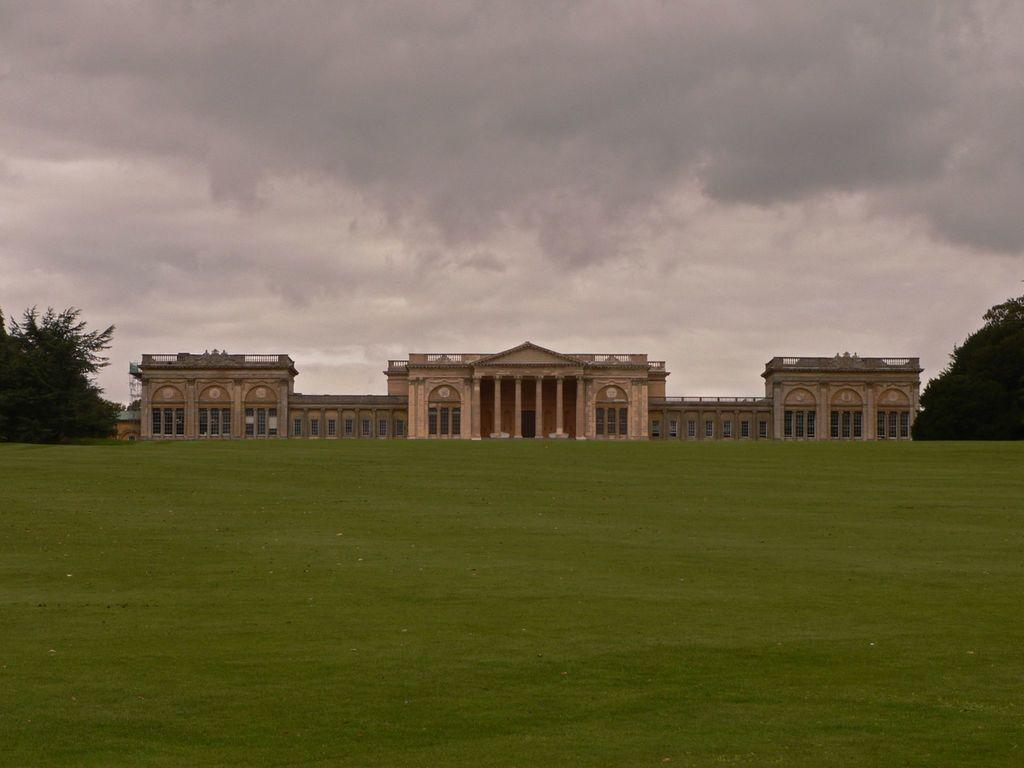What type of structures can be seen in the image? There are buildings in the image. What other natural elements are present in the image? There are trees in the image. What part of the environment is visible in the image? The ground and the sky are visible in the image. What can be observed in the sky in the image? Clouds are present in the sky. How many nails can be seen holding the beds together in the image? There are no beds or nails present in the image. What type of cars can be seen driving on the roads in the image? There are no cars or roads visible in the image. 